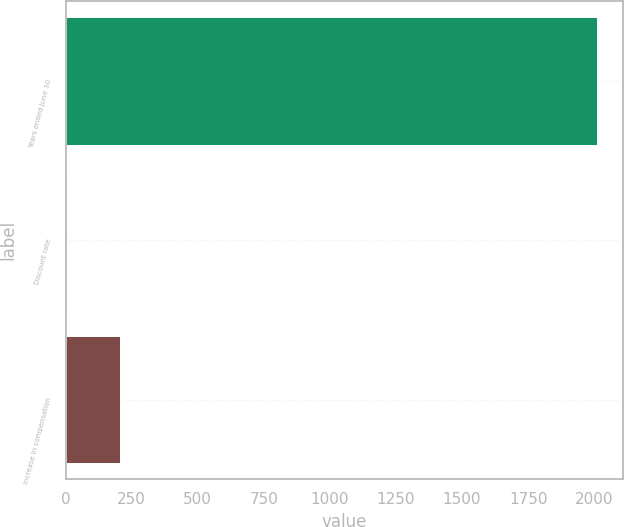Convert chart to OTSL. <chart><loc_0><loc_0><loc_500><loc_500><bar_chart><fcel>Years ended June 30<fcel>Discount rate<fcel>Increase in compensation<nl><fcel>2010<fcel>5.25<fcel>205.73<nl></chart> 